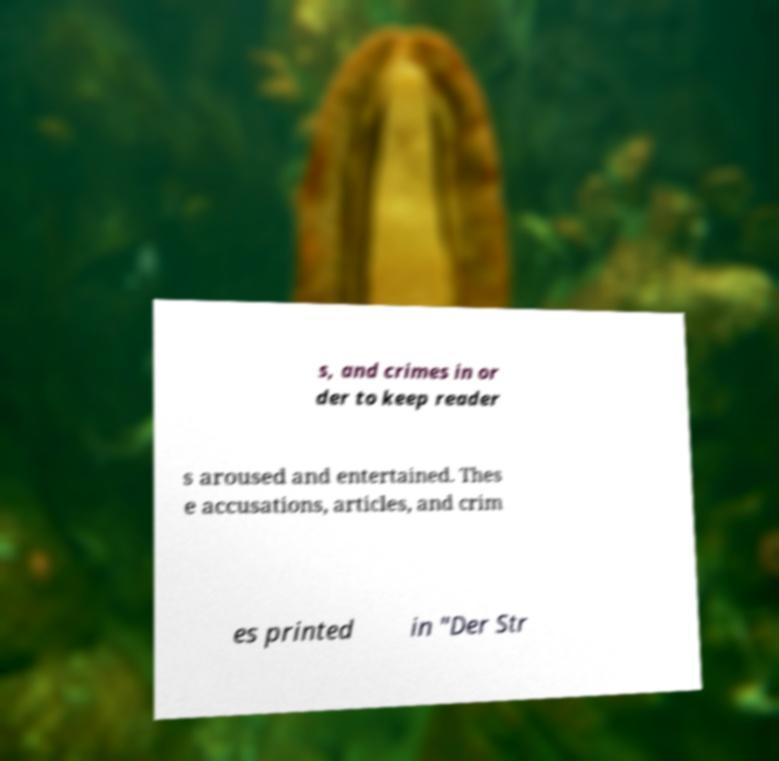Can you read and provide the text displayed in the image?This photo seems to have some interesting text. Can you extract and type it out for me? s, and crimes in or der to keep reader s aroused and entertained. Thes e accusations, articles, and crim es printed in "Der Str 